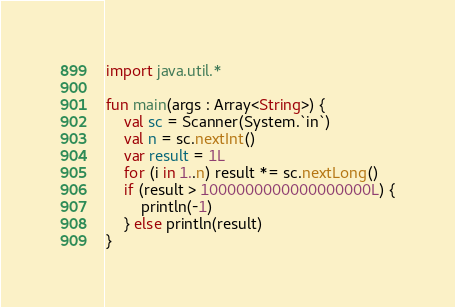Convert code to text. <code><loc_0><loc_0><loc_500><loc_500><_Kotlin_>import java.util.*

fun main(args : Array<String>) {
    val sc = Scanner(System.`in`)
    val n = sc.nextInt()
    var result = 1L
    for (i in 1..n) result *= sc.nextLong()
    if (result > 1000000000000000000L) {
        println(-1)
    } else println(result)
}
</code> 